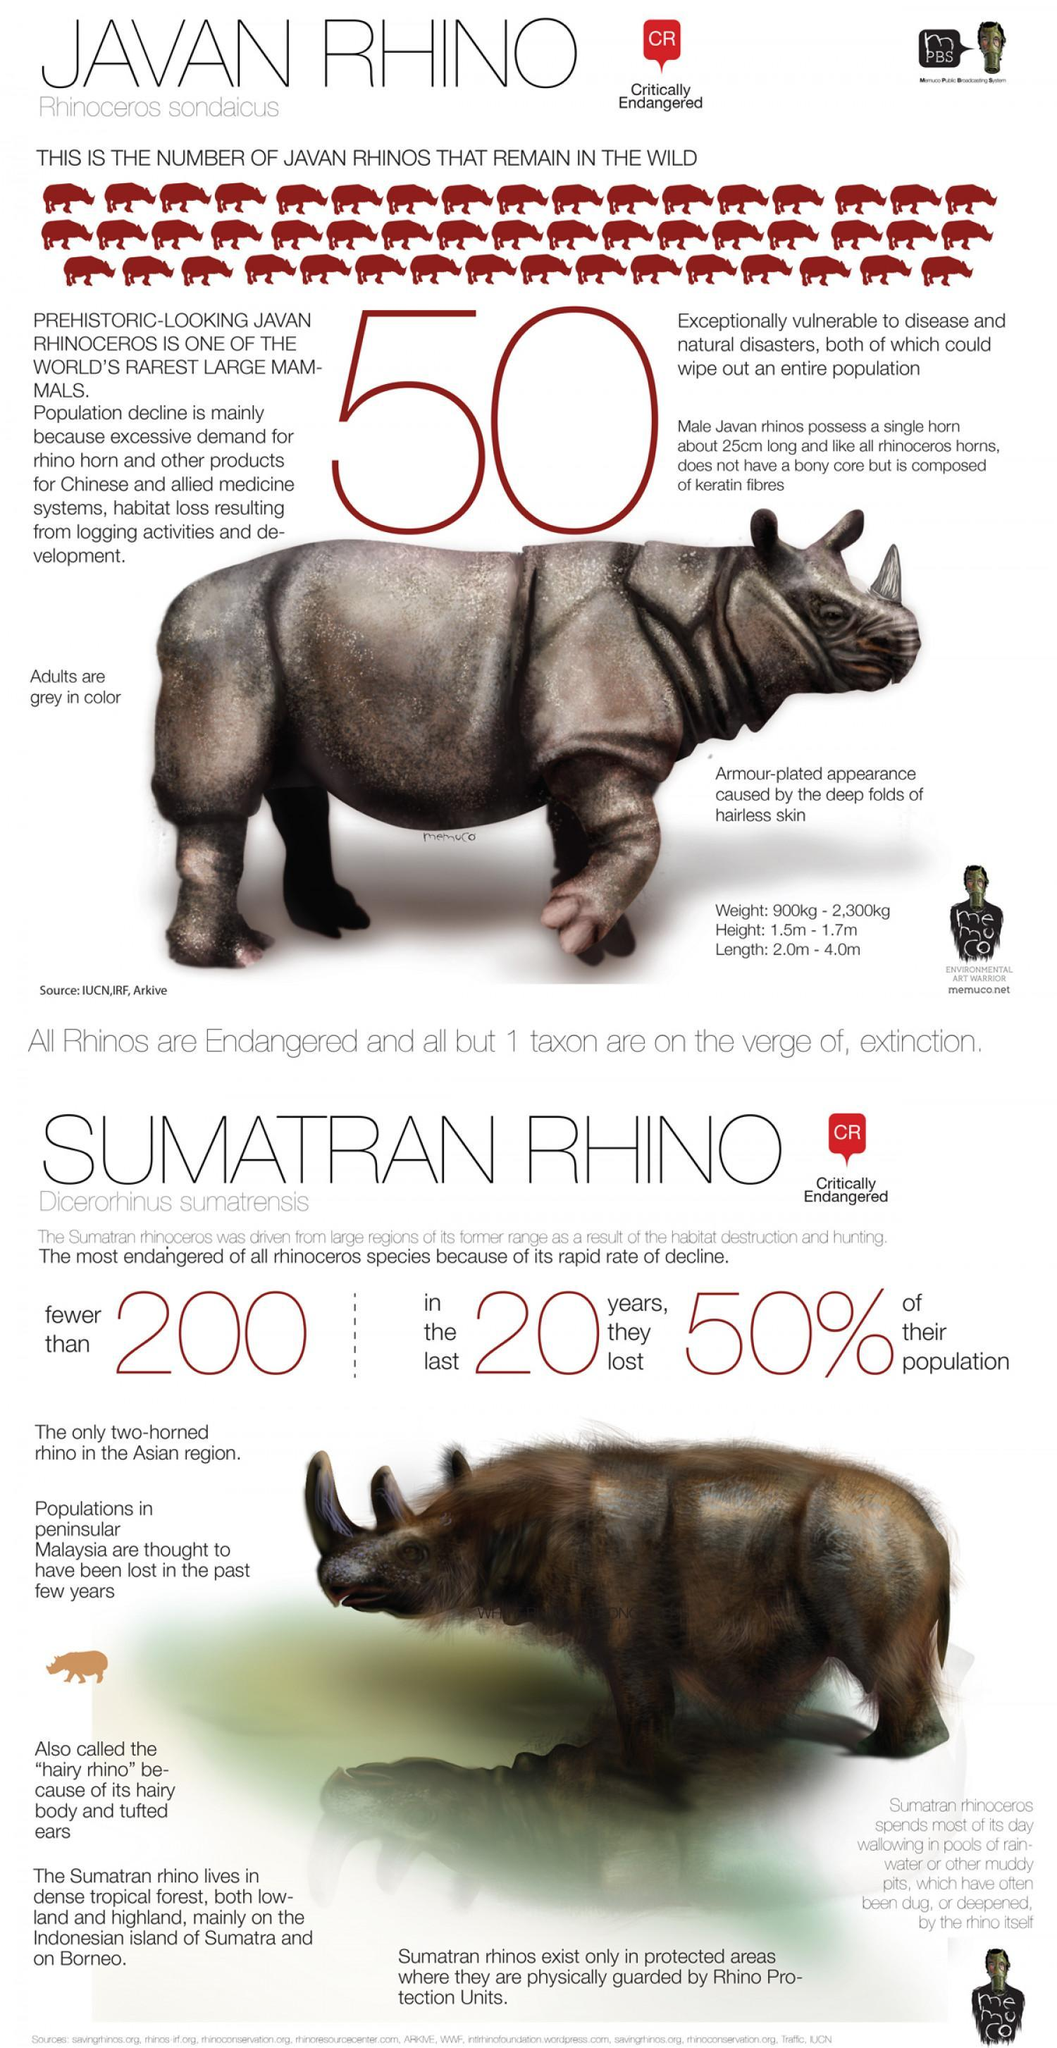What is the total "minimum height and length" of Javan Rhinos?
Answer the question with a short phrase. 3.5m What is the total "maximum height and length" of Javan Rhinos? 5.7m 